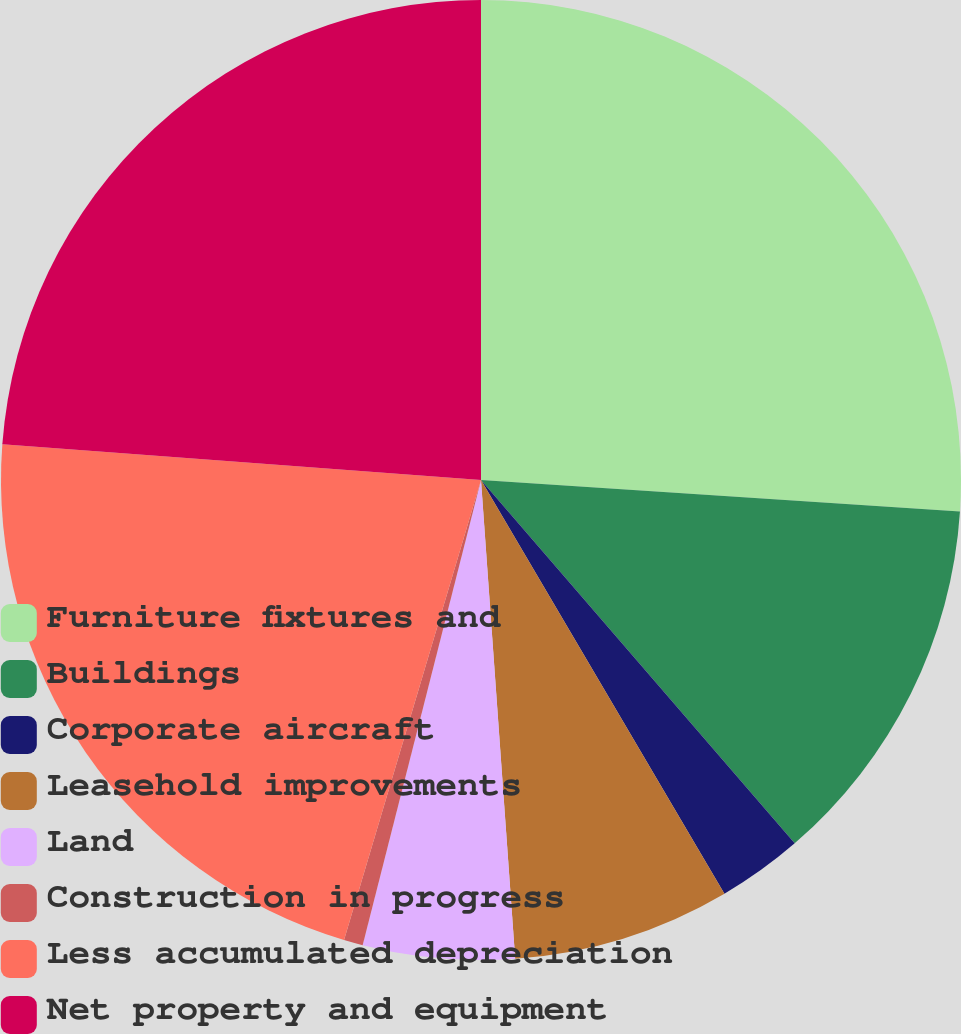<chart> <loc_0><loc_0><loc_500><loc_500><pie_chart><fcel>Furniture fixtures and<fcel>Buildings<fcel>Corporate aircraft<fcel>Leasehold improvements<fcel>Land<fcel>Construction in progress<fcel>Less accumulated depreciation<fcel>Net property and equipment<nl><fcel>26.04%<fcel>12.62%<fcel>2.87%<fcel>7.33%<fcel>5.1%<fcel>0.64%<fcel>21.58%<fcel>23.81%<nl></chart> 